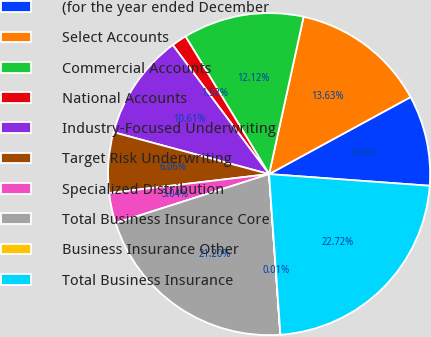Convert chart to OTSL. <chart><loc_0><loc_0><loc_500><loc_500><pie_chart><fcel>(for the year ended December<fcel>Select Accounts<fcel>Commercial Accounts<fcel>National Accounts<fcel>Industry-Focused Underwriting<fcel>Target Risk Underwriting<fcel>Specialized Distribution<fcel>Total Business Insurance Core<fcel>Business Insurance Other<fcel>Total Business Insurance<nl><fcel>9.09%<fcel>13.63%<fcel>12.12%<fcel>1.52%<fcel>10.61%<fcel>6.06%<fcel>3.04%<fcel>21.2%<fcel>0.01%<fcel>22.72%<nl></chart> 